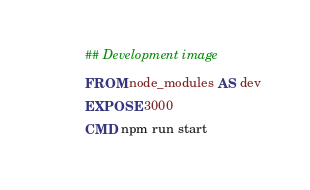Convert code to text. <code><loc_0><loc_0><loc_500><loc_500><_Dockerfile_>## Development image
FROM node_modules AS dev
EXPOSE 3000
CMD npm run start
</code> 